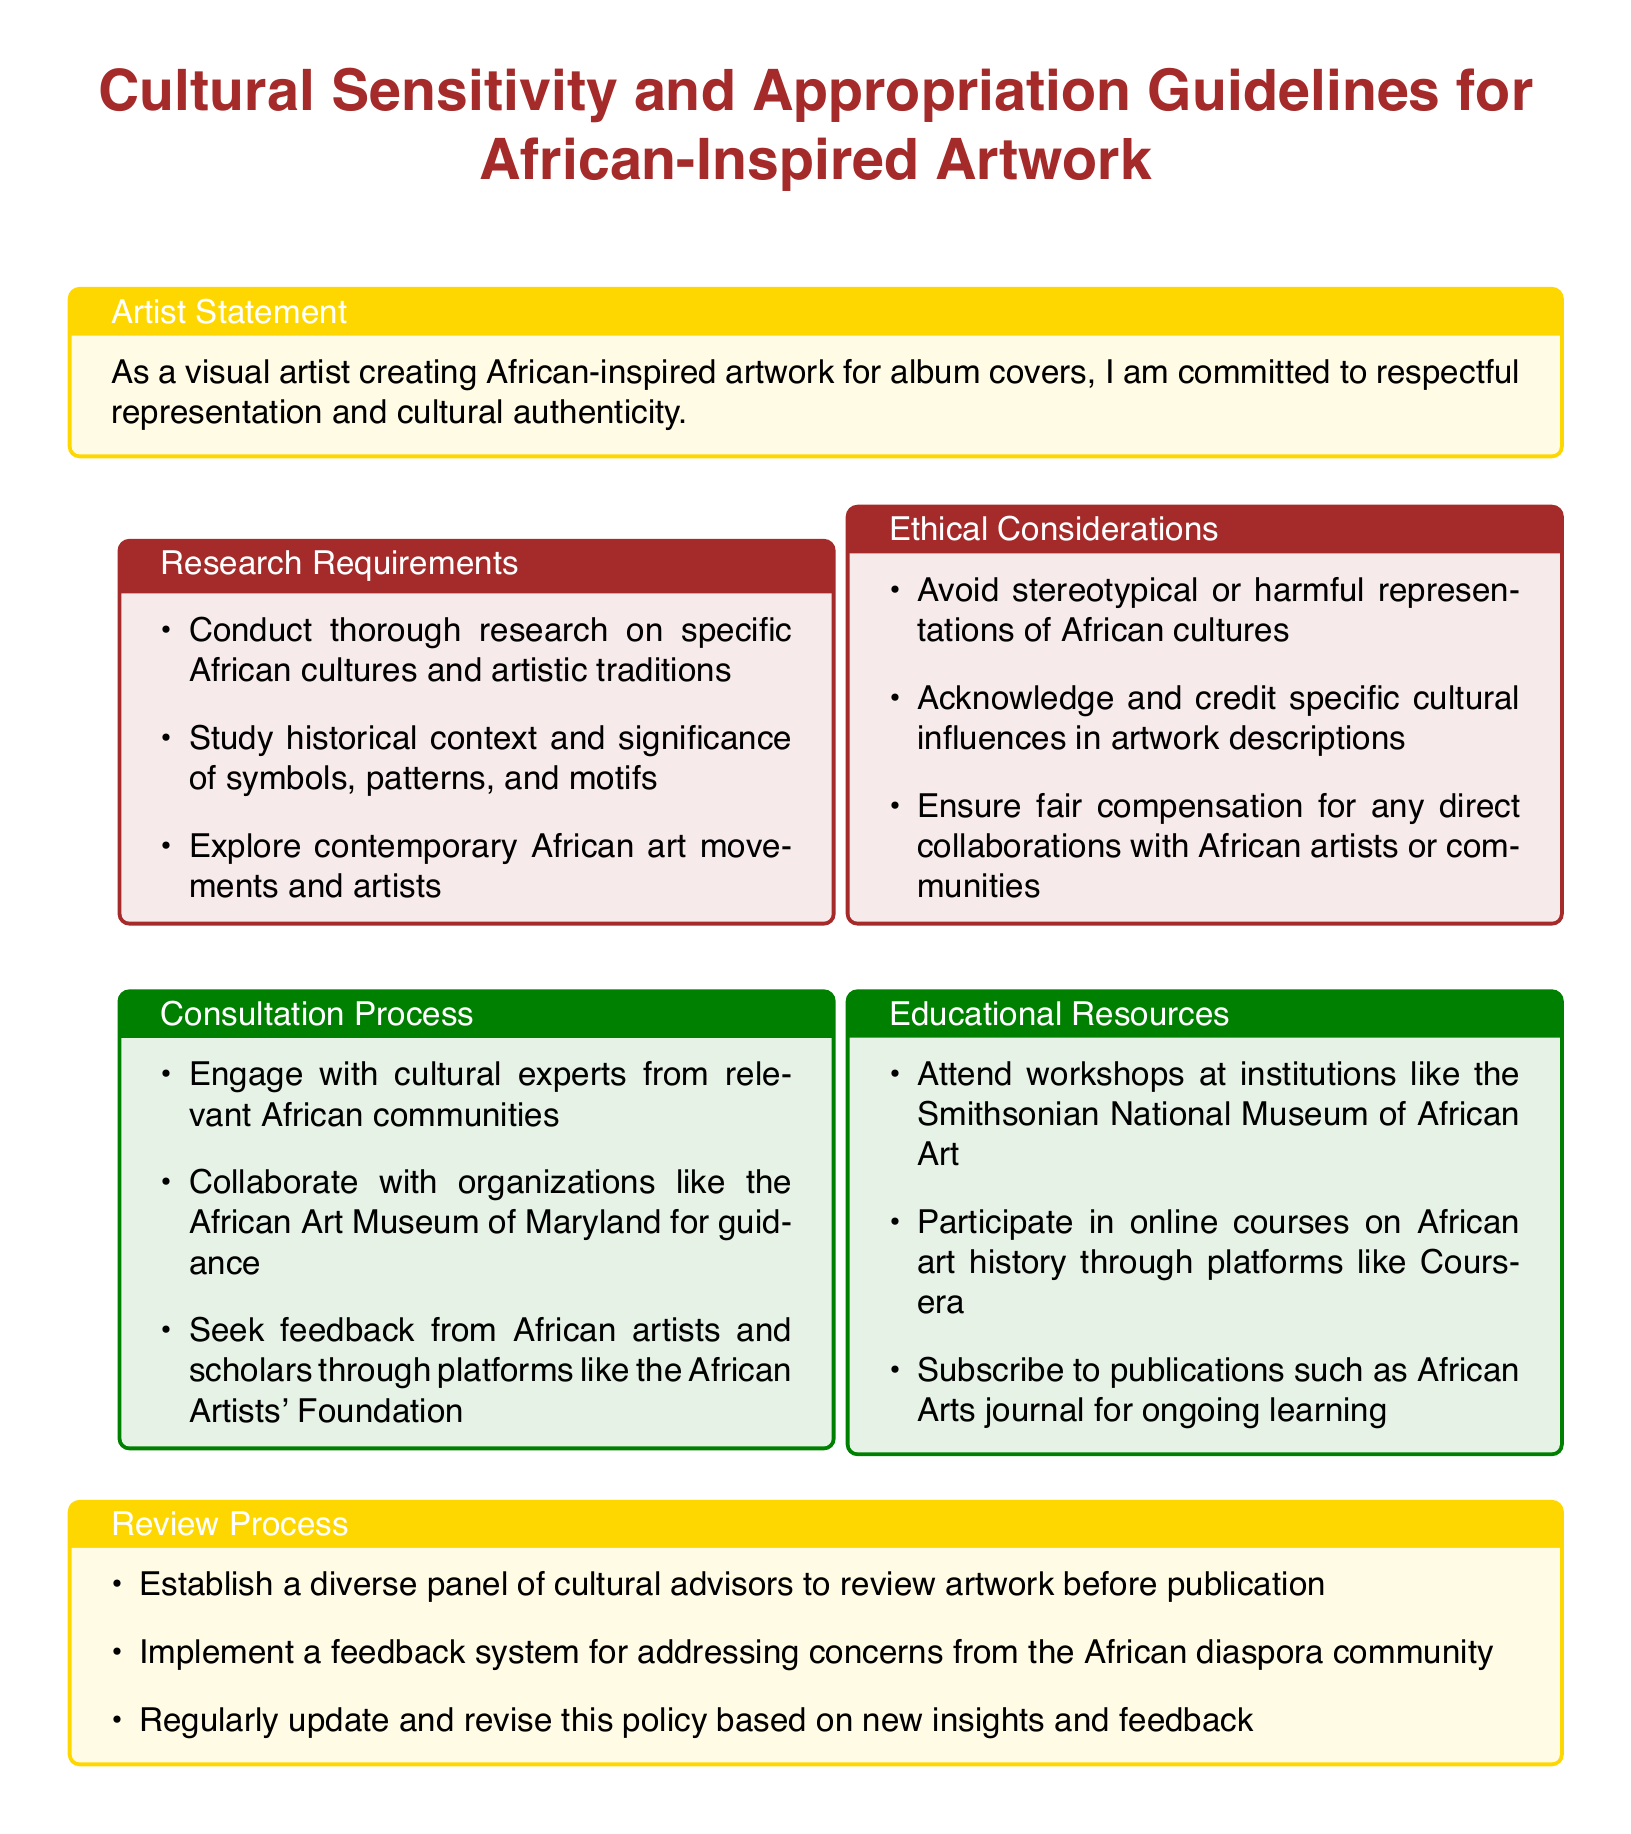What is the title of the document? The title of the document is the main heading that introduces the policy, which is found at the center of the document.
Answer: Cultural Sensitivity and Appropriation Guidelines for African-Inspired Artwork What are the three research requirements listed? The research requirements are specific items enumerated in the first colored box of the document.
Answer: Conduct thorough research on specific African cultures and artistic traditions, Study historical context and significance of symbols, patterns, and motifs, Explore contemporary African art movements and artists Which institutions are suggested for attending workshops? The document mentions specific institutions in the educational resources section that offer workshops.
Answer: Smithsonian National Museum of African Art What should be avoided according to the ethical considerations? The ethical considerations highlight specific aspects to be avoided when creating artwork.
Answer: Stereotypical or harmful representations of African cultures What does the review process include regarding cultural advisors? The review process pertains to the involvement of specific parties in reviewing artwork as seen in the corresponding section.
Answer: Establish a diverse panel of cultural advisors to review artwork before publication How many areas are covered in the consultation process? The consultation process is presented as a list of items that can be counted.
Answer: Three areas 